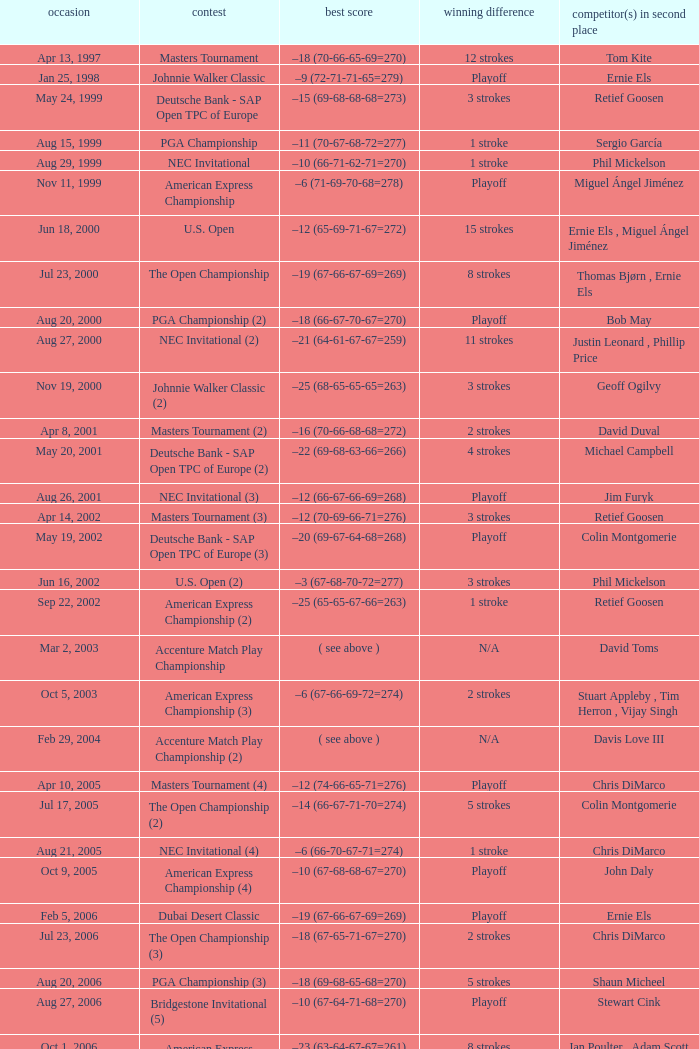Who is Runner(s)-up that has a Date of may 24, 1999? Retief Goosen. 